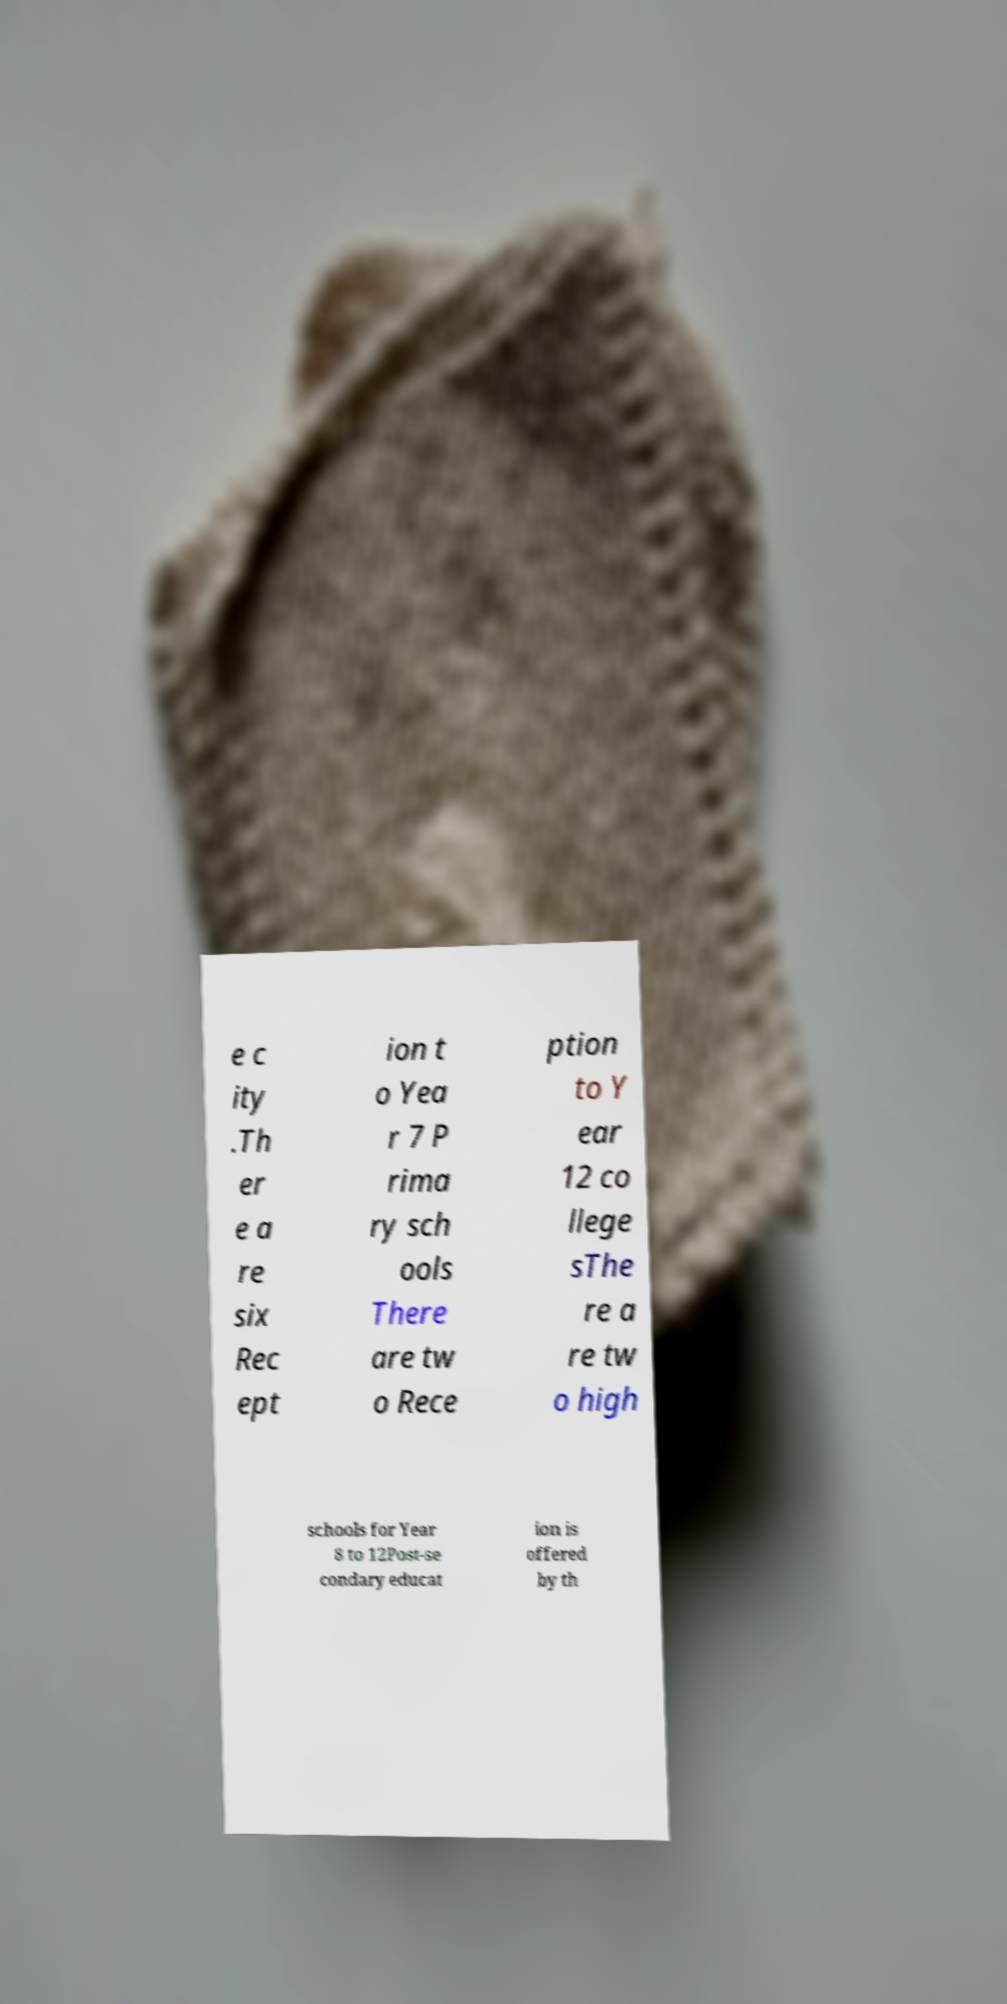Please read and relay the text visible in this image. What does it say? e c ity .Th er e a re six Rec ept ion t o Yea r 7 P rima ry sch ools There are tw o Rece ption to Y ear 12 co llege sThe re a re tw o high schools for Year 8 to 12Post-se condary educat ion is offered by th 